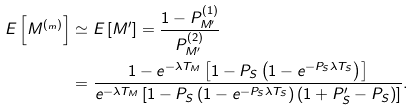<formula> <loc_0><loc_0><loc_500><loc_500>E \left [ M ^ { ( _ { m } ) } \right ] & \simeq E \left [ M ^ { \prime } \right ] = \frac { 1 - P _ { M ^ { \prime } } ^ { ( 1 ) } } { P _ { M ^ { \prime } } ^ { ( 2 ) } } \\ & = \frac { 1 - e ^ { - \lambda T _ { M } } \left [ 1 - P _ { S } \left ( 1 - e ^ { - P _ { S } \lambda T _ { S } } \right ) \right ] } { e ^ { - \lambda T _ { M } } \left [ 1 - P _ { S } \left ( 1 - e ^ { - P _ { S } \lambda T _ { S } } \right ) \left ( 1 + P _ { S } ^ { \prime } - P _ { S } \right ) \right ] } .</formula> 